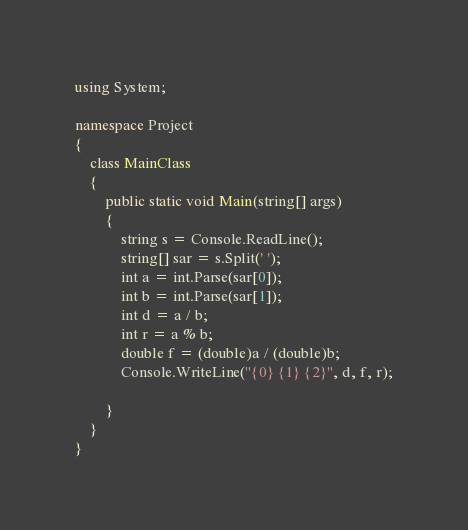<code> <loc_0><loc_0><loc_500><loc_500><_C#_>using System;

namespace Project
{
	class MainClass
	{
		public static void Main(string[] args)
		{
			string s = Console.ReadLine();
			string[] sar = s.Split(' ');
			int a = int.Parse(sar[0]);
			int b = int.Parse(sar[1]);
			int d = a / b;
			int r = a % b;
			double f = (double)a / (double)b;
			Console.WriteLine("{0} {1} {2}", d, f, r);

		}
	}
}</code> 